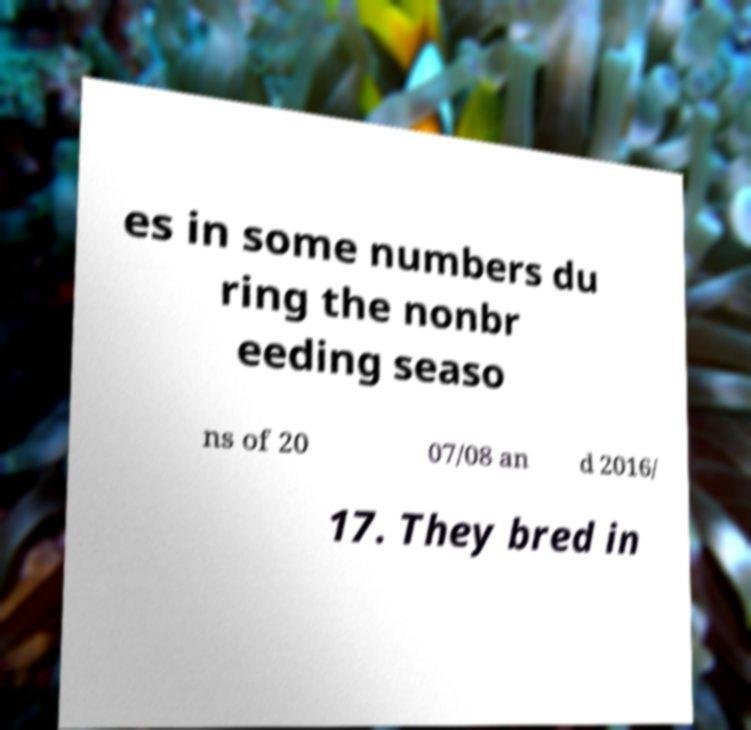What messages or text are displayed in this image? I need them in a readable, typed format. es in some numbers du ring the nonbr eeding seaso ns of 20 07/08 an d 2016/ 17. They bred in 